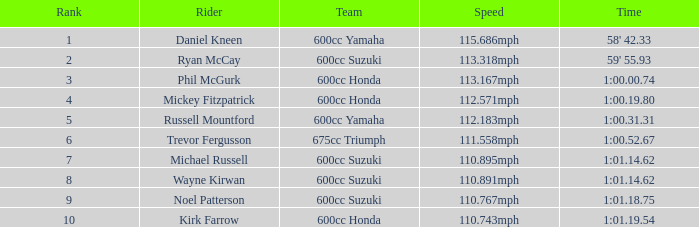How many ranks have michael russell as the rider? 7.0. 